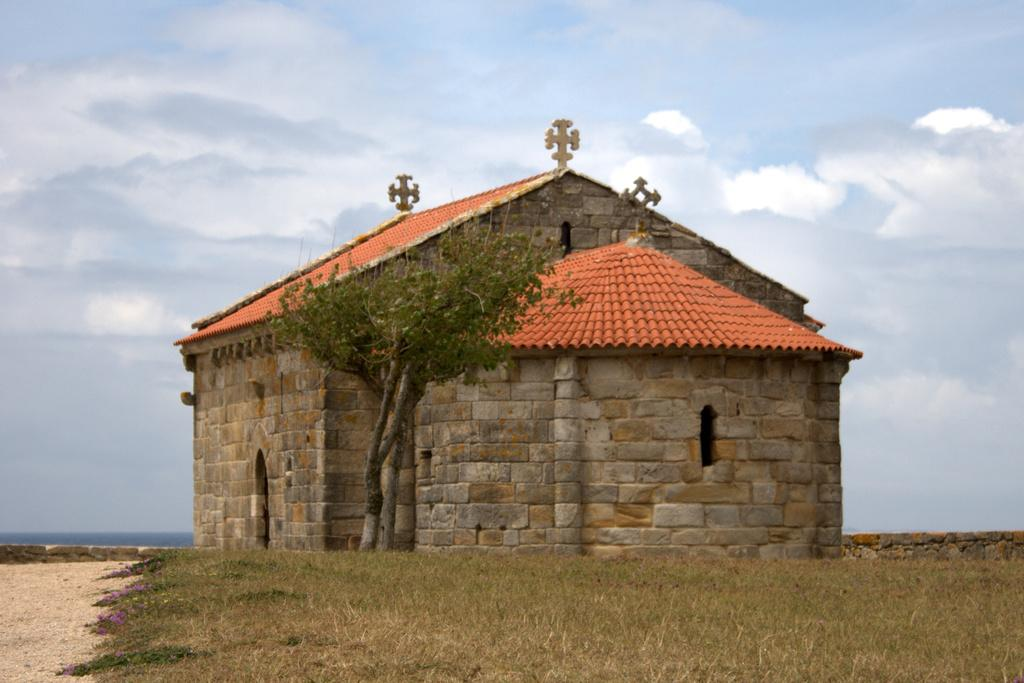What is the main structure in the picture? There is a building in the picture. What is located beside the building? There is a tree and greenery grass beside the building. How would you describe the sky in the picture? The sky is cloudy. What type of clover can be seen growing near the building? There is no clover visible in the image; only a tree and greenery grass are present. 